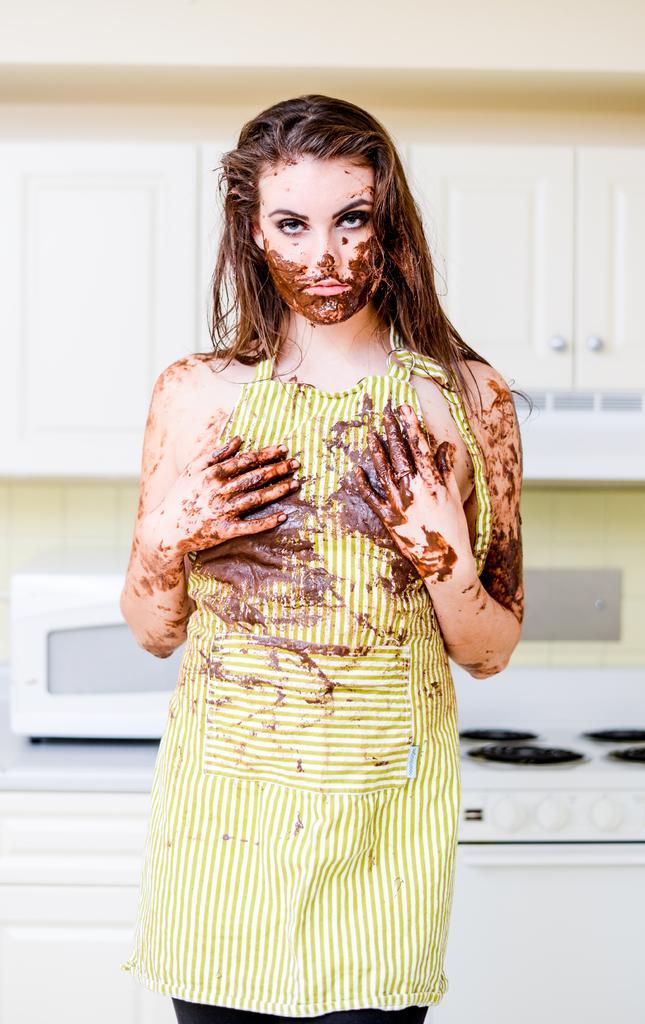Describe this image in one or two sentences. In this image I can see a beautiful woman is standing, she wore green and white color top. There is the chocolate cream on her hands and face, behind her there is a oven. It looks like a kitchen room. 